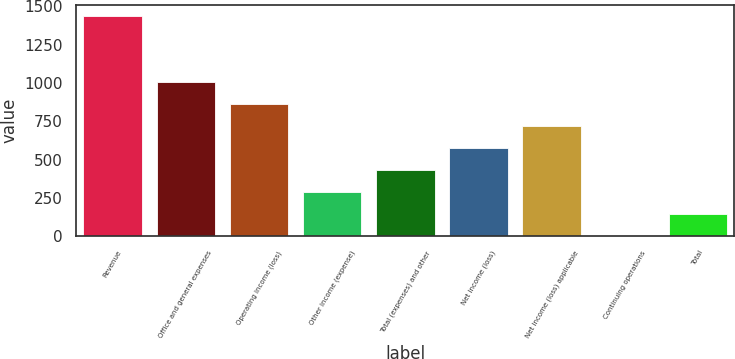<chart> <loc_0><loc_0><loc_500><loc_500><bar_chart><fcel>Revenue<fcel>Office and general expenses<fcel>Operating income (loss)<fcel>Other income (expense)<fcel>Total (expenses) and other<fcel>Net income (loss)<fcel>Net income (loss) applicable<fcel>Continuing operations<fcel>Total<nl><fcel>1439.7<fcel>1007.88<fcel>863.93<fcel>288.14<fcel>432.09<fcel>576.03<fcel>719.98<fcel>0.25<fcel>144.2<nl></chart> 